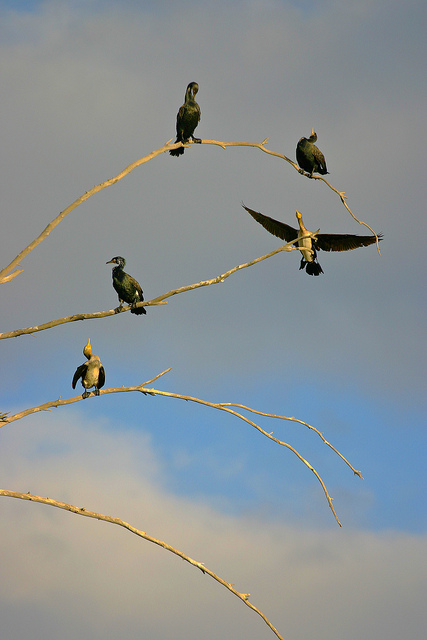How many birds are there? There are five birds, perched and soaring against the sky, showcasing the dynamic postures of avian life. 